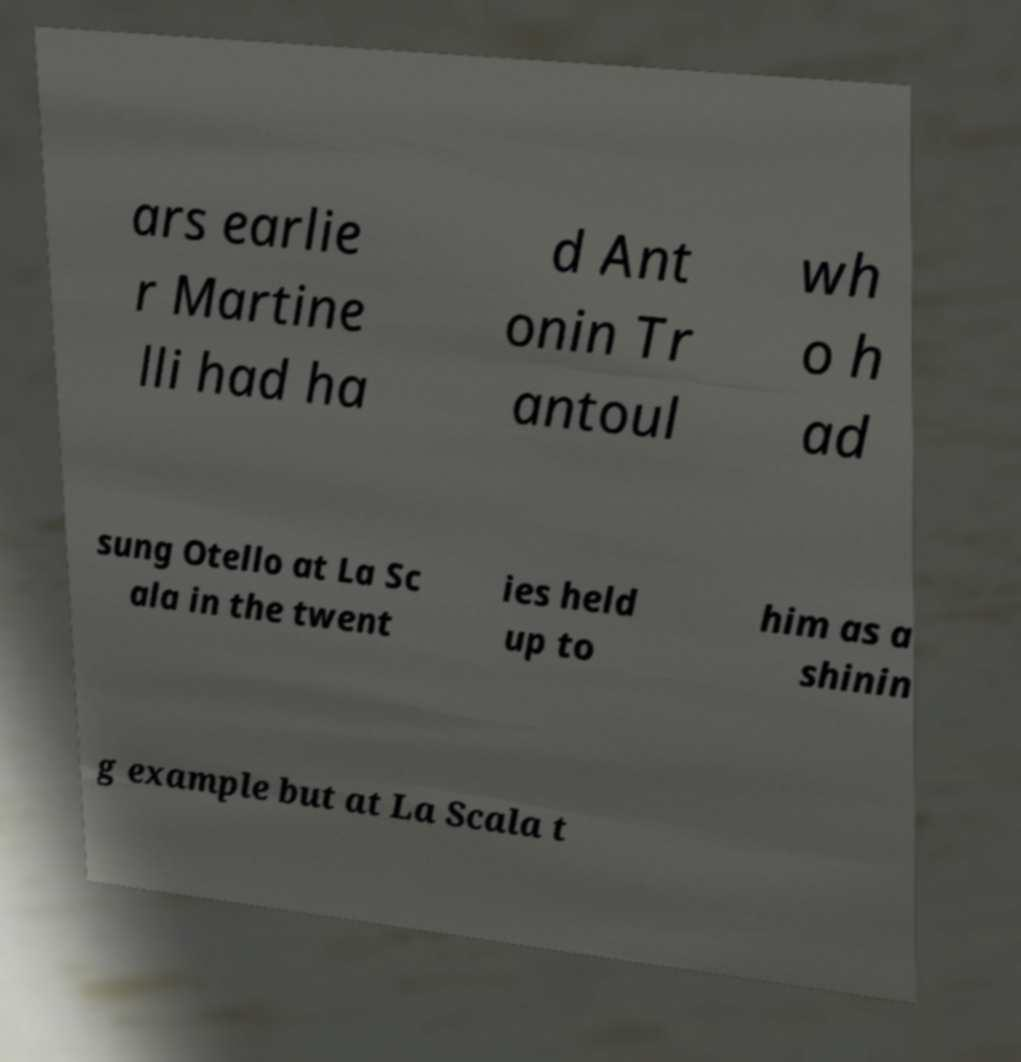Please identify and transcribe the text found in this image. ars earlie r Martine lli had ha d Ant onin Tr antoul wh o h ad sung Otello at La Sc ala in the twent ies held up to him as a shinin g example but at La Scala t 